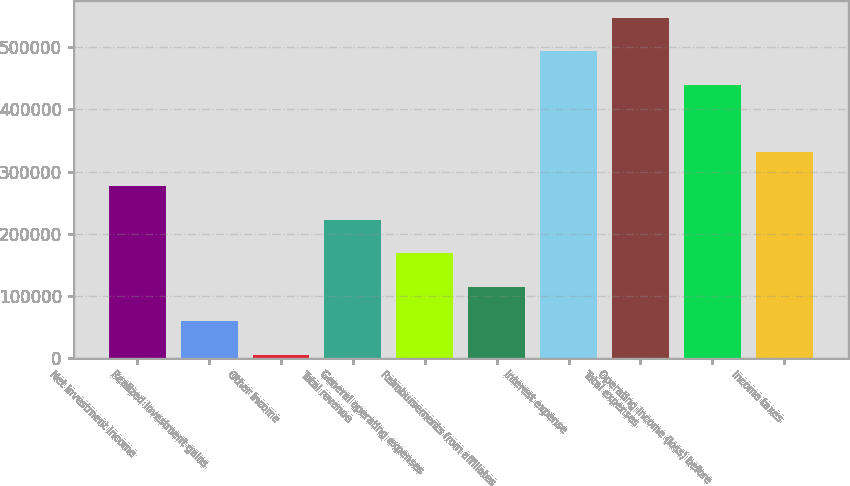Convert chart to OTSL. <chart><loc_0><loc_0><loc_500><loc_500><bar_chart><fcel>Net investment income<fcel>Realized investment gains<fcel>Other income<fcel>Total revenue<fcel>General operating expenses<fcel>Reimbursements from affiliates<fcel>Interest expense<fcel>Total expenses<fcel>Operating income (loss) before<fcel>Income taxes<nl><fcel>276668<fcel>59447.3<fcel>5142<fcel>222363<fcel>168058<fcel>113753<fcel>493890<fcel>548195<fcel>439584<fcel>330974<nl></chart> 